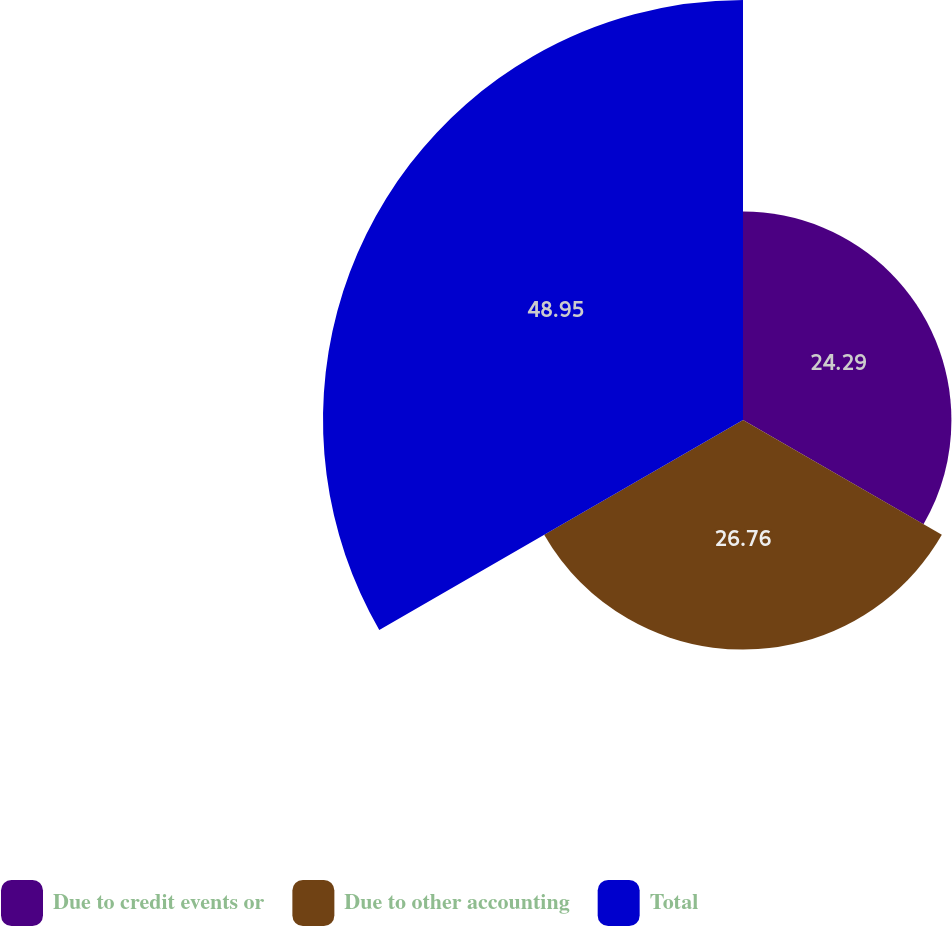<chart> <loc_0><loc_0><loc_500><loc_500><pie_chart><fcel>Due to credit events or<fcel>Due to other accounting<fcel>Total<nl><fcel>24.29%<fcel>26.76%<fcel>48.95%<nl></chart> 